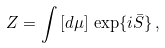<formula> <loc_0><loc_0><loc_500><loc_500>Z = \int \, [ d \mu ] \, \exp \{ i \bar { S } \} \, ,</formula> 